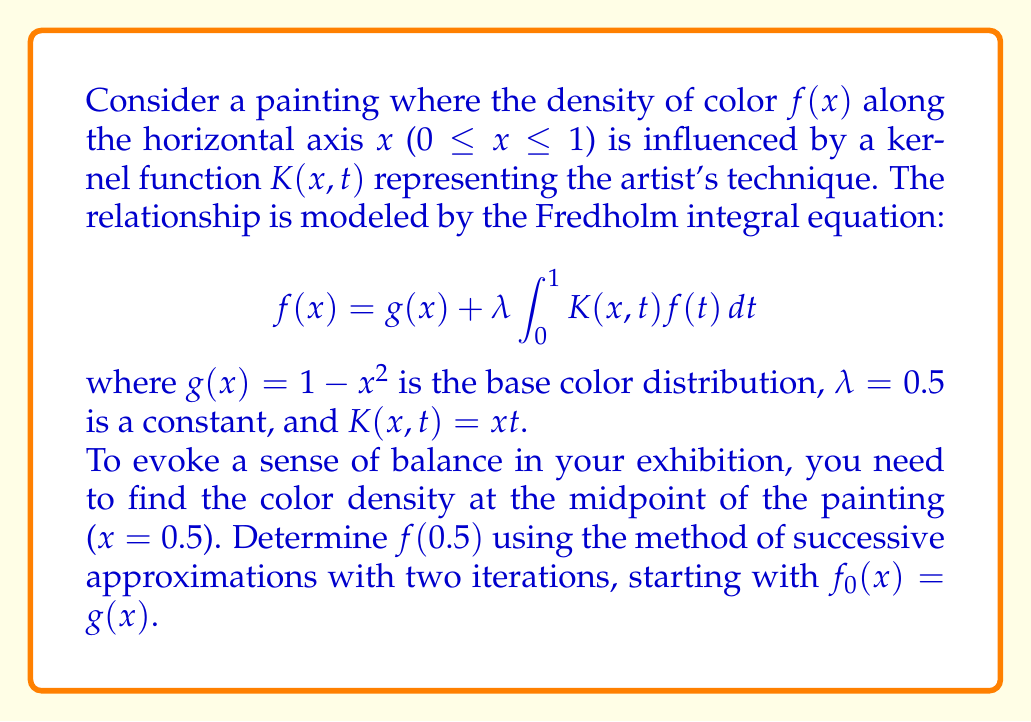Provide a solution to this math problem. Let's solve this step-by-step using the method of successive approximations:

1) We start with $f_0(x) = g(x) = 1 - x^2$

2) For the first iteration, we calculate $f_1(x)$:

   $$f_1(x) = g(x) + λ \int_0^1 K(x,t)f_0(t)dt$$
   $$f_1(x) = (1 - x^2) + 0.5 \int_0^1 xt(1 - t^2)dt$$

3) Let's solve the integral:
   $$\int_0^1 xt(1 - t^2)dt = x \int_0^1 (t - t^3)dt = x[\frac{t^2}{2} - \frac{t^4}{4}]_0^1 = x(\frac{1}{2} - \frac{1}{4}) = \frac{x}{4}$$

4) Therefore, $f_1(x) = (1 - x^2) + 0.5 \cdot \frac{x}{4} = 1 - x^2 + \frac{x}{8}$

5) For the second iteration, we calculate $f_2(x)$:

   $$f_2(x) = g(x) + λ \int_0^1 K(x,t)f_1(t)dt$$
   $$f_2(x) = (1 - x^2) + 0.5 \int_0^1 xt(1 - t^2 + \frac{t}{8})dt$$

6) Let's solve this new integral:
   $$\int_0^1 xt(1 - t^2 + \frac{t}{8})dt = x \int_0^1 (t - t^3 + \frac{t^2}{8})dt$$
   $$= x[\frac{t^2}{2} - \frac{t^4}{4} + \frac{t^3}{24}]_0^1 = x(\frac{1}{2} - \frac{1}{4} + \frac{1}{24}) = \frac{13x}{48}$$

7) Therefore, $f_2(x) = (1 - x^2) + 0.5 \cdot \frac{13x}{48} = 1 - x^2 + \frac{13x}{96}$

8) Now, we can calculate $f_2(0.5)$:
   $$f_2(0.5) = 1 - (0.5)^2 + \frac{13(0.5)}{96} = 1 - 0.25 + \frac{13}{192} ≈ 0.8177$$
Answer: $f(0.5) ≈ 0.8177$ 